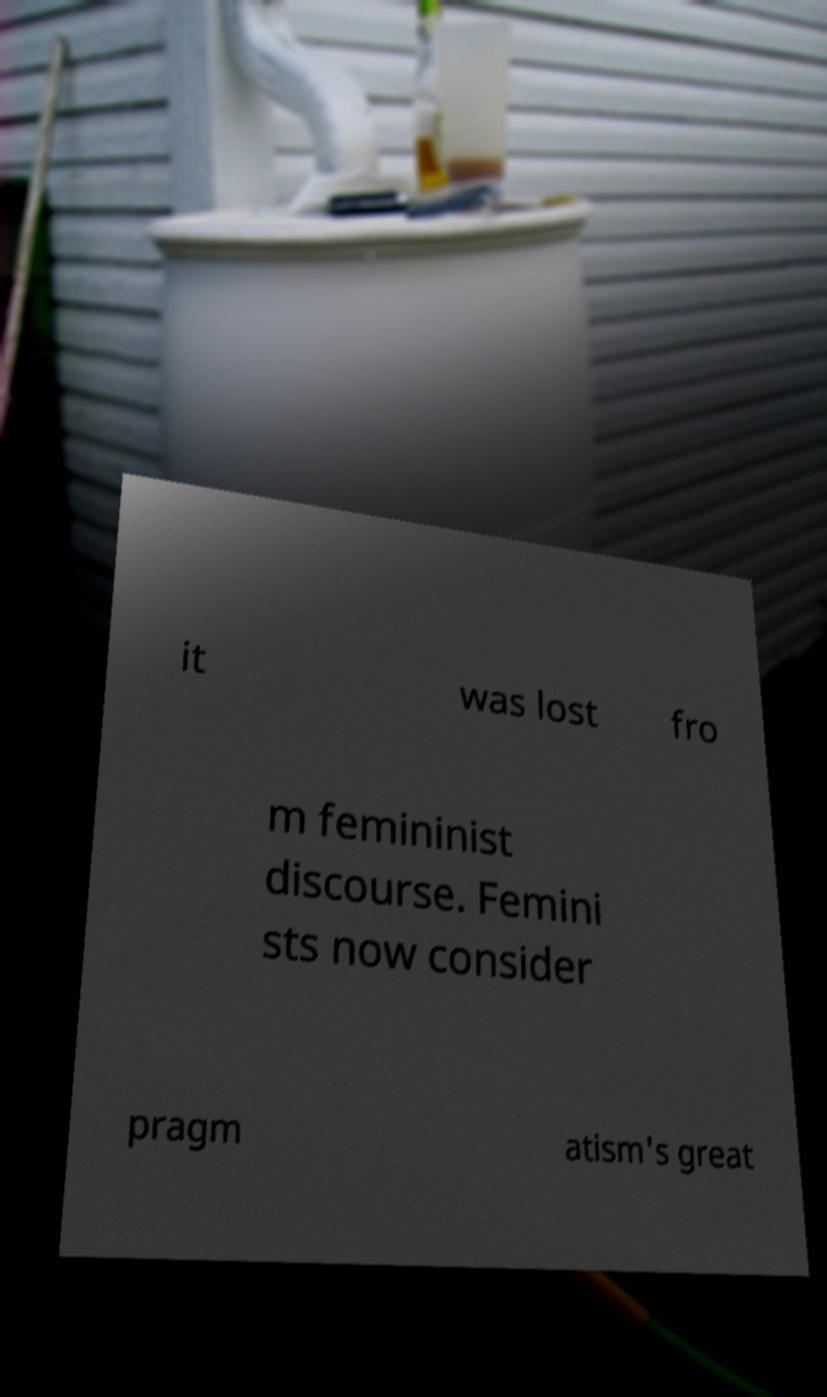Please identify and transcribe the text found in this image. it was lost fro m femininist discourse. Femini sts now consider pragm atism's great 